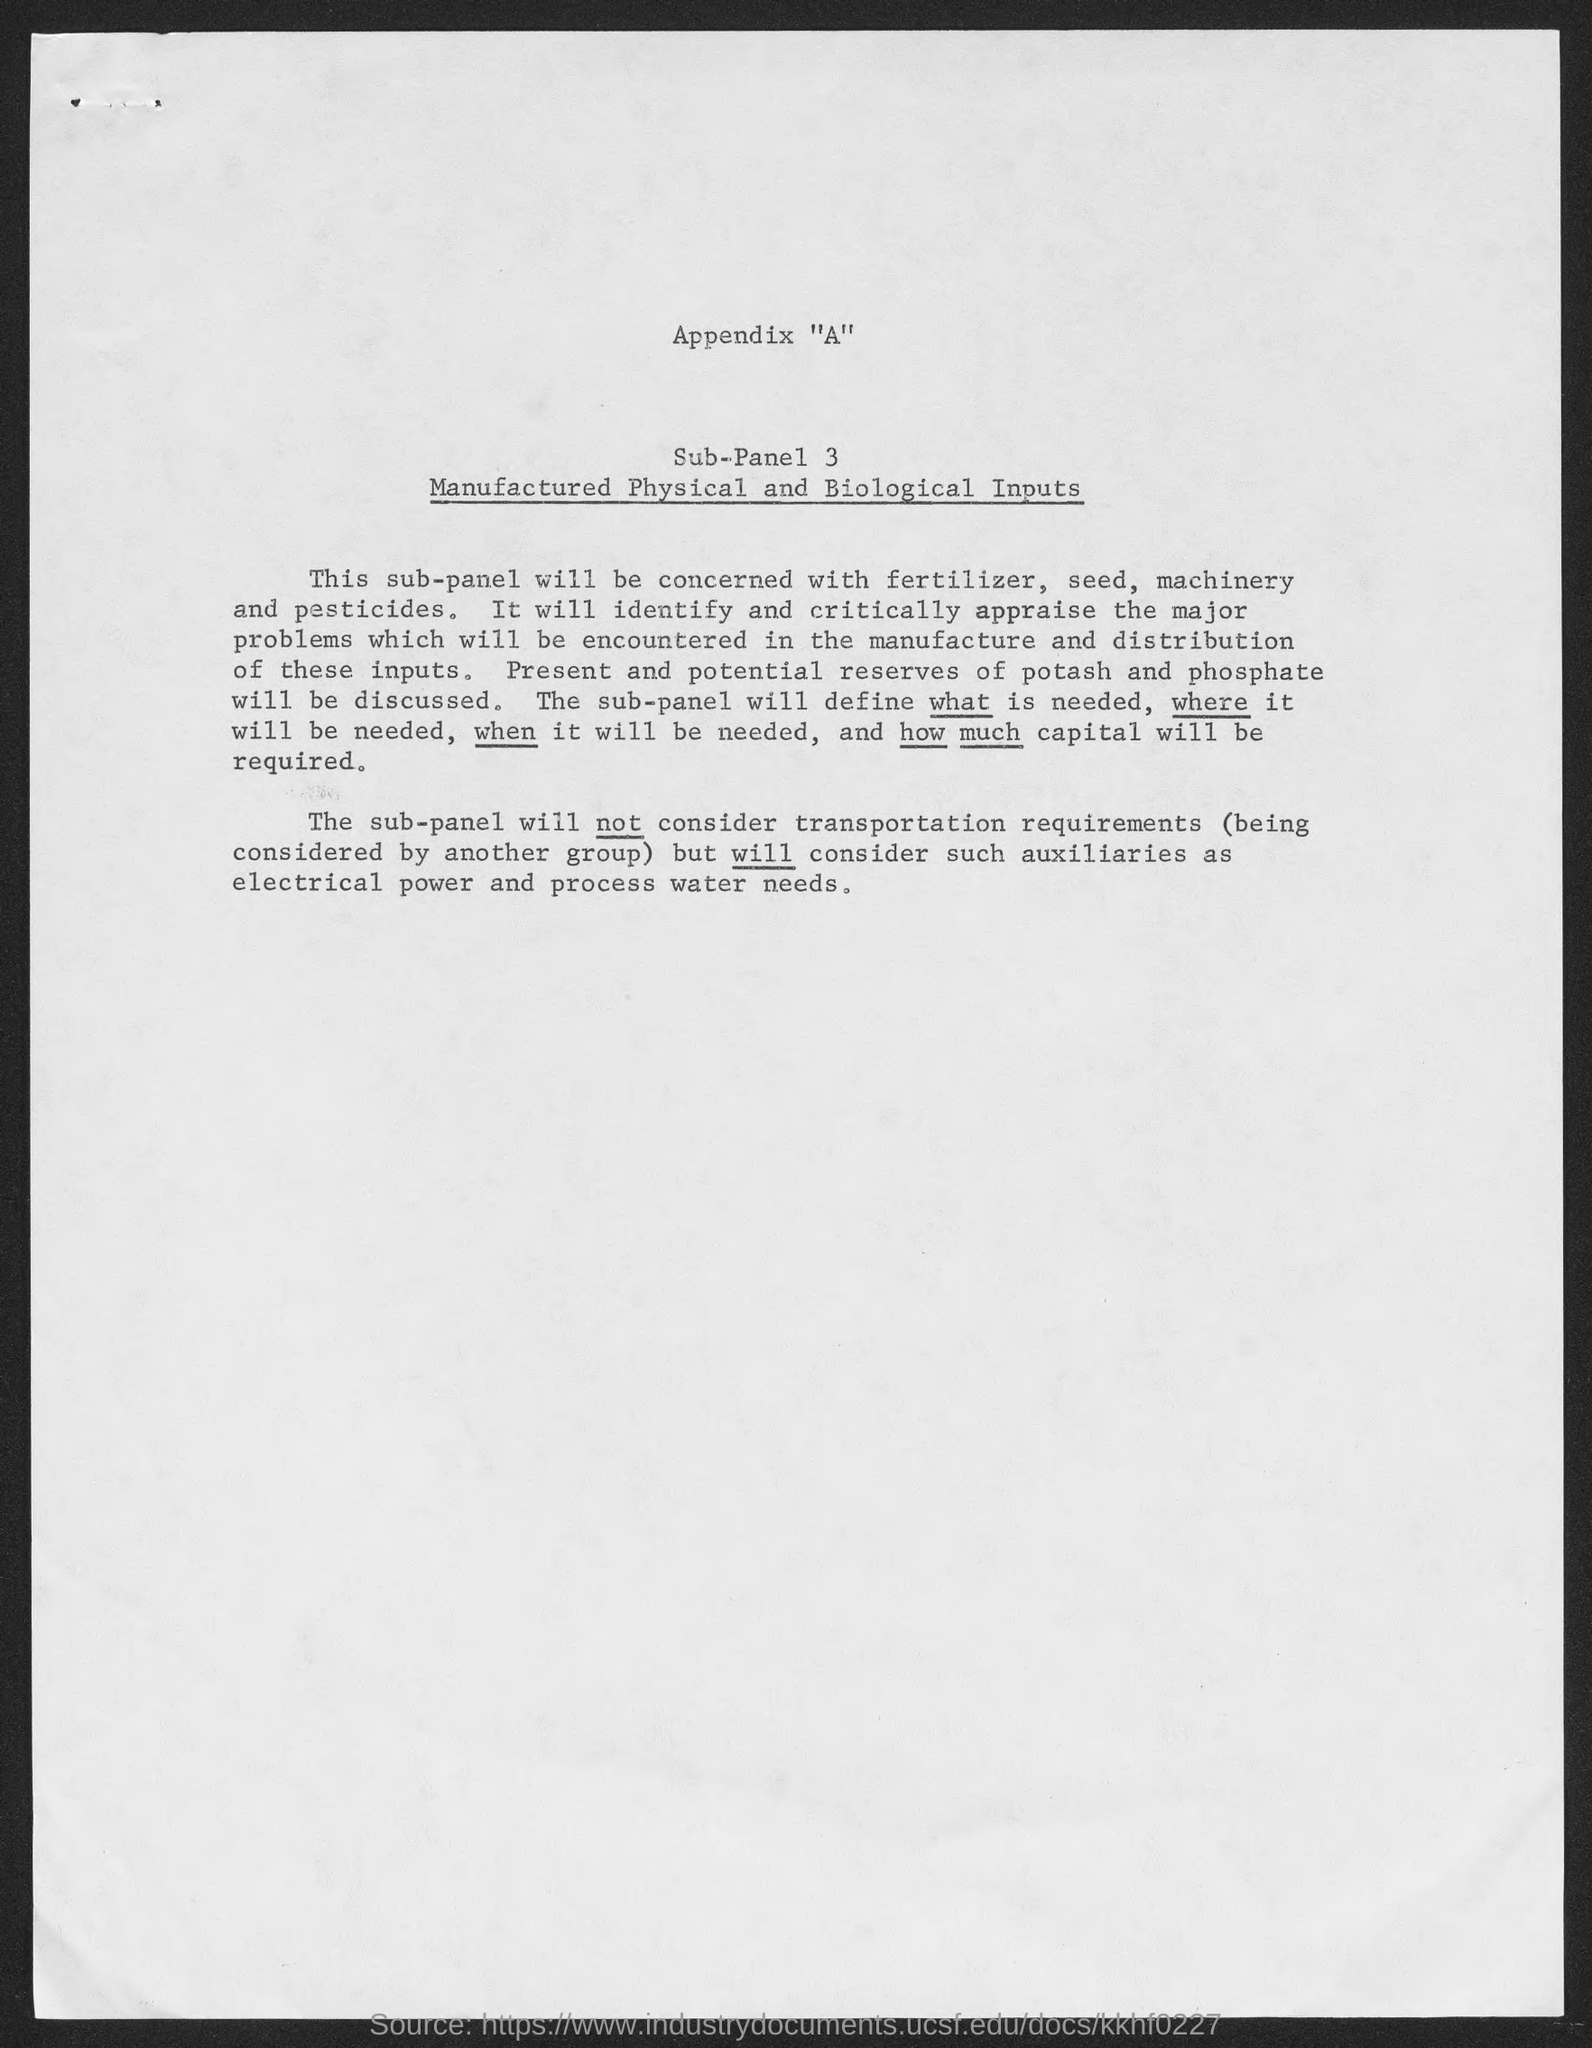What is the title of sub-panel 3?
Ensure brevity in your answer.  Manufactured Physical and Biological Inputs. 